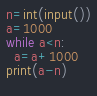Convert code to text. <code><loc_0><loc_0><loc_500><loc_500><_Python_>n=int(input())
a=1000
while a<n:
  a=a+1000
print(a-n)
  
</code> 